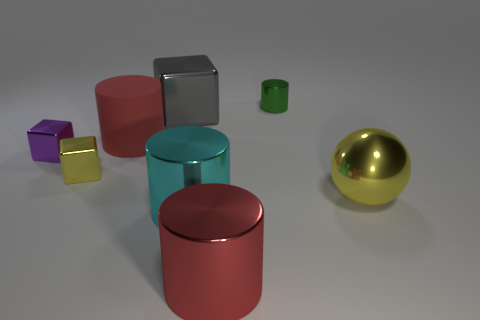The thing that is the same color as the metal ball is what shape?
Give a very brief answer. Cube. What is the color of the cylinder on the right side of the cylinder that is in front of the big cyan cylinder?
Provide a succinct answer. Green. There is a big ball; does it have the same color as the metallic cylinder that is behind the big yellow object?
Give a very brief answer. No. What size is the yellow thing that is made of the same material as the ball?
Offer a very short reply. Small. There is another cylinder that is the same color as the rubber cylinder; what size is it?
Keep it short and to the point. Large. Does the small cylinder have the same color as the sphere?
Give a very brief answer. No. There is a small metallic cube in front of the small metallic cube that is behind the small yellow metallic cube; are there any small things that are behind it?
Make the answer very short. Yes. What number of other purple shiny blocks have the same size as the purple block?
Ensure brevity in your answer.  0. There is a yellow object to the right of the small green metallic object; is its size the same as the yellow thing left of the tiny cylinder?
Provide a succinct answer. No. There is a tiny shiny thing that is both in front of the gray thing and on the right side of the purple cube; what is its shape?
Offer a terse response. Cube. 